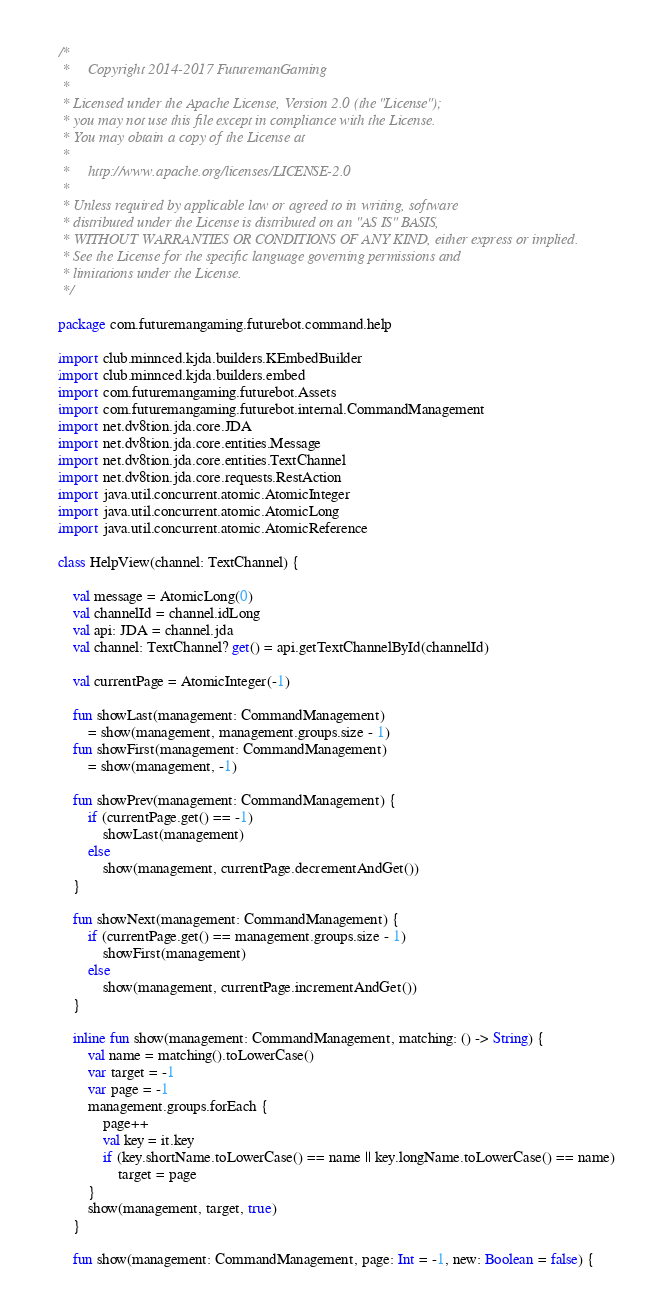Convert code to text. <code><loc_0><loc_0><loc_500><loc_500><_Kotlin_>/*
 *     Copyright 2014-2017 FuturemanGaming
 *
 * Licensed under the Apache License, Version 2.0 (the "License");
 * you may not use this file except in compliance with the License.
 * You may obtain a copy of the License at
 *
 *     http://www.apache.org/licenses/LICENSE-2.0
 *
 * Unless required by applicable law or agreed to in writing, software
 * distributed under the License is distributed on an "AS IS" BASIS,
 * WITHOUT WARRANTIES OR CONDITIONS OF ANY KIND, either express or implied.
 * See the License for the specific language governing permissions and
 * limitations under the License.
 */

package com.futuremangaming.futurebot.command.help

import club.minnced.kjda.builders.KEmbedBuilder
import club.minnced.kjda.builders.embed
import com.futuremangaming.futurebot.Assets
import com.futuremangaming.futurebot.internal.CommandManagement
import net.dv8tion.jda.core.JDA
import net.dv8tion.jda.core.entities.Message
import net.dv8tion.jda.core.entities.TextChannel
import net.dv8tion.jda.core.requests.RestAction
import java.util.concurrent.atomic.AtomicInteger
import java.util.concurrent.atomic.AtomicLong
import java.util.concurrent.atomic.AtomicReference

class HelpView(channel: TextChannel) {

    val message = AtomicLong(0)
    val channelId = channel.idLong
    val api: JDA = channel.jda
    val channel: TextChannel? get() = api.getTextChannelById(channelId)

    val currentPage = AtomicInteger(-1)

    fun showLast(management: CommandManagement)
        = show(management, management.groups.size - 1)
    fun showFirst(management: CommandManagement)
        = show(management, -1)

    fun showPrev(management: CommandManagement) {
        if (currentPage.get() == -1)
            showLast(management)
        else
            show(management, currentPage.decrementAndGet())
    }

    fun showNext(management: CommandManagement) {
        if (currentPage.get() == management.groups.size - 1)
            showFirst(management)
        else
            show(management, currentPage.incrementAndGet())
    }

    inline fun show(management: CommandManagement, matching: () -> String) {
        val name = matching().toLowerCase()
        var target = -1
        var page = -1
        management.groups.forEach {
            page++
            val key = it.key
            if (key.shortName.toLowerCase() == name || key.longName.toLowerCase() == name)
                target = page
        }
        show(management, target, true)
    }

    fun show(management: CommandManagement, page: Int = -1, new: Boolean = false) {</code> 